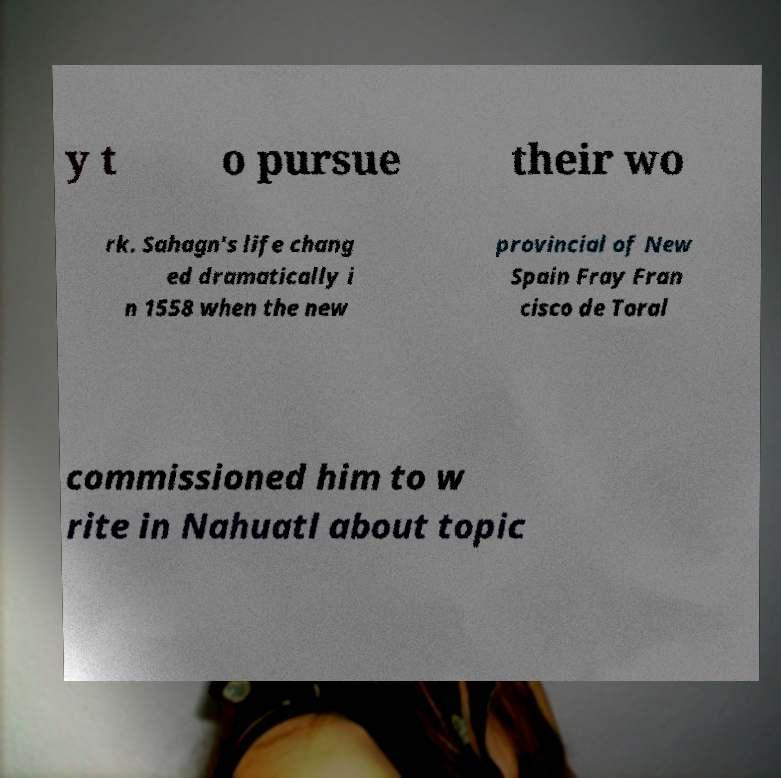Please read and relay the text visible in this image. What does it say? y t o pursue their wo rk. Sahagn's life chang ed dramatically i n 1558 when the new provincial of New Spain Fray Fran cisco de Toral commissioned him to w rite in Nahuatl about topic 